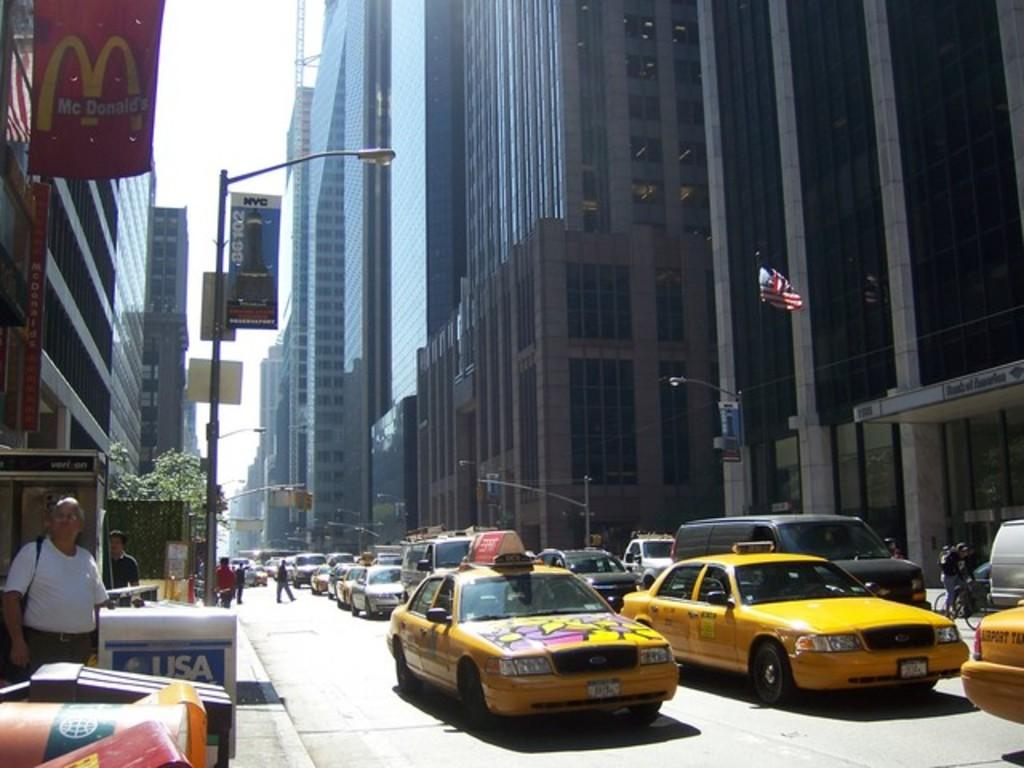<image>
Write a terse but informative summary of the picture. USA Today newspaper boxes are available on busy city streets. 